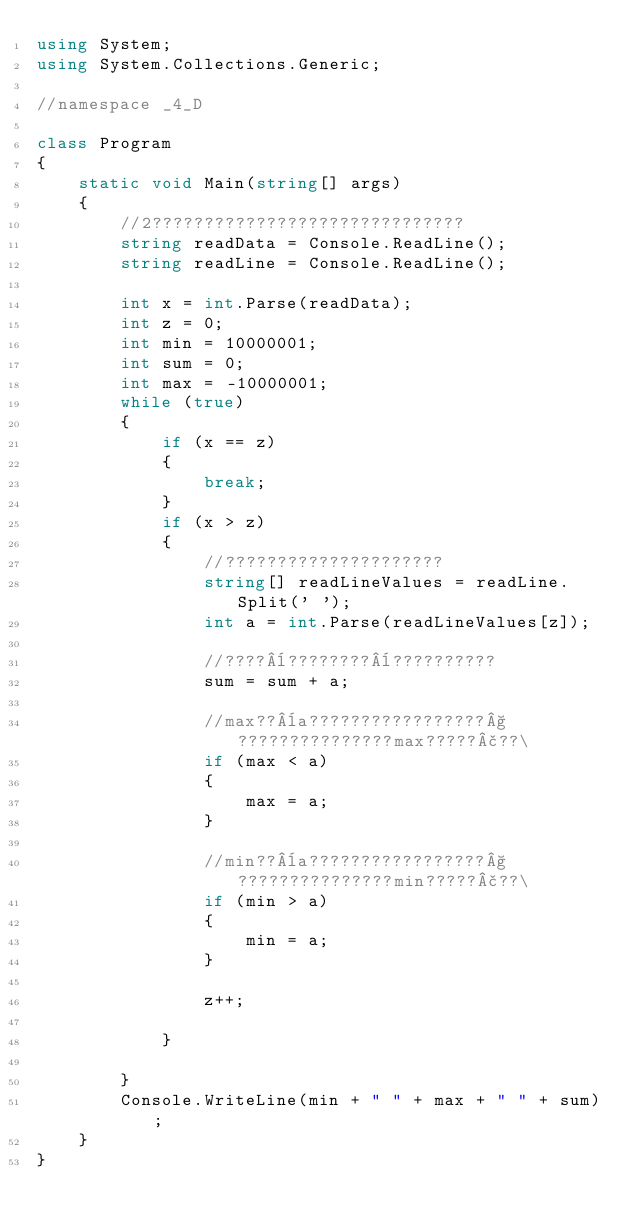<code> <loc_0><loc_0><loc_500><loc_500><_C#_>using System;
using System.Collections.Generic;

//namespace _4_D

class Program
{
    static void Main(string[] args)
    {
        //2??????????????????????????????
        string readData = Console.ReadLine();
        string readLine = Console.ReadLine();

        int x = int.Parse(readData);
        int z = 0;
        int min = 10000001;
        int sum = 0;
        int max = -10000001;
        while (true)
        {
            if (x == z)
            {
                break;
            }
            if (x > z)
            {
                //?????????????????????
                string[] readLineValues = readLine.Split(' ');
                int a = int.Parse(readLineValues[z]);

                //????¨????????¨??????????
                sum = sum + a;

                //max??¨a?????????????????§???????????????max?????£??\
                if (max < a)
                {
                    max = a;
                }

                //min??¨a?????????????????§???????????????min?????£??\
                if (min > a)
                {
                    min = a;
                }

                z++;

            }

        }
        Console.WriteLine(min + " " + max + " " + sum);
    }
}</code> 